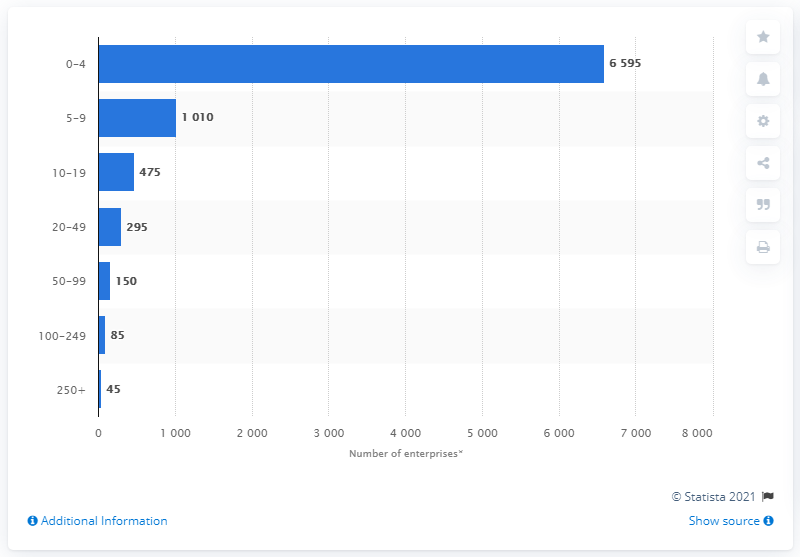Outline some significant characteristics in this image. According to the data, there were 45 travel and tourism sector enterprises that employed 250 or more people in the given time period. The question is asking for the minimum number of enterprises that can be created in a specific number of stages. The second largest enterprises belong to the band size of 5-9. 